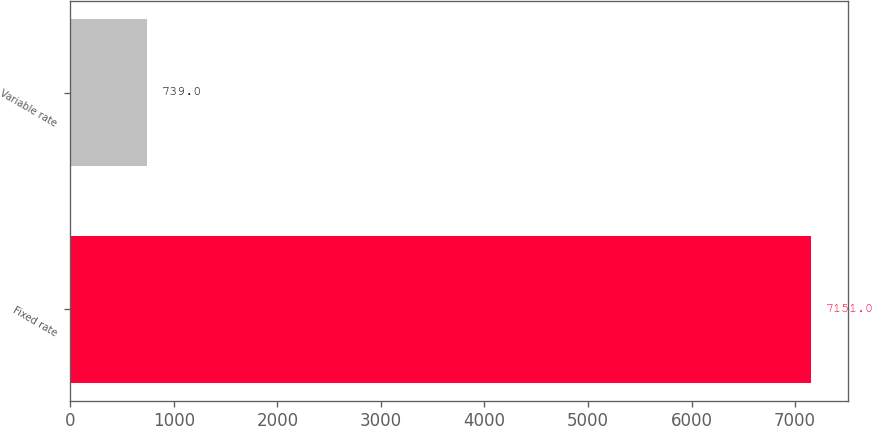<chart> <loc_0><loc_0><loc_500><loc_500><bar_chart><fcel>Fixed rate<fcel>Variable rate<nl><fcel>7151<fcel>739<nl></chart> 